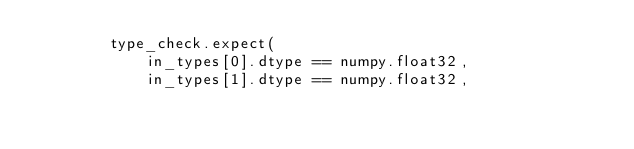Convert code to text. <code><loc_0><loc_0><loc_500><loc_500><_Python_>        type_check.expect(
            in_types[0].dtype == numpy.float32,
            in_types[1].dtype == numpy.float32,</code> 